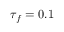<formula> <loc_0><loc_0><loc_500><loc_500>\tau _ { f } = 0 . 1</formula> 